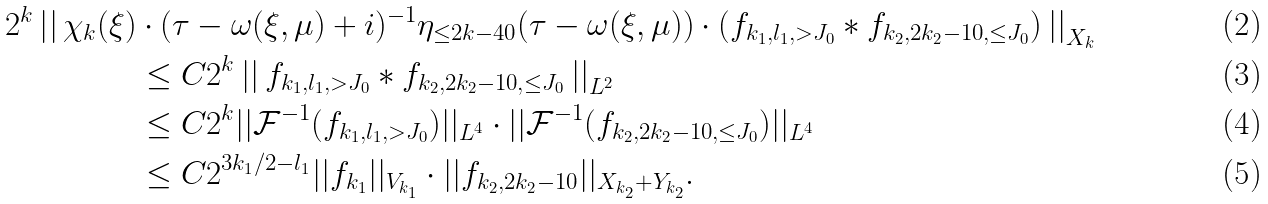<formula> <loc_0><loc_0><loc_500><loc_500>2 ^ { k } \left | \right | \chi _ { k } ( \xi ) & \cdot ( \tau - \omega ( \xi , \mu ) + i ) ^ { - 1 } \eta _ { \leq 2 k - 4 0 } ( \tau - \omega ( \xi , \mu ) ) \cdot ( f _ { k _ { 1 } , l _ { 1 } , > J _ { 0 } } \ast f _ { k _ { 2 } , 2 k _ { 2 } - 1 0 , \leq J _ { 0 } } ) \left | \right | _ { X _ { k } } \\ & \leq C 2 ^ { k } \left | \right | f _ { k _ { 1 } , l _ { 1 } , > J _ { 0 } } \ast f _ { k _ { 2 } , 2 k _ { 2 } - 1 0 , \leq J _ { 0 } } \left | \right | _ { L ^ { 2 } } \\ & \leq C 2 ^ { k } | | \mathcal { F } ^ { - 1 } ( f _ { k _ { 1 } , l _ { 1 } , > J _ { 0 } } ) | | _ { L ^ { 4 } } \cdot | | \mathcal { F } ^ { - 1 } ( f _ { k _ { 2 } , 2 k _ { 2 } - 1 0 , \leq J _ { 0 } } ) | | _ { L ^ { 4 } } \\ & \leq C 2 ^ { 3 k _ { 1 } / 2 - l _ { 1 } } | | f _ { k _ { 1 } } | | _ { V _ { k _ { 1 } } } \cdot | | f _ { k _ { 2 } , 2 k _ { 2 } - 1 0 } | | _ { X _ { k _ { 2 } } + Y _ { k _ { 2 } } } .</formula> 